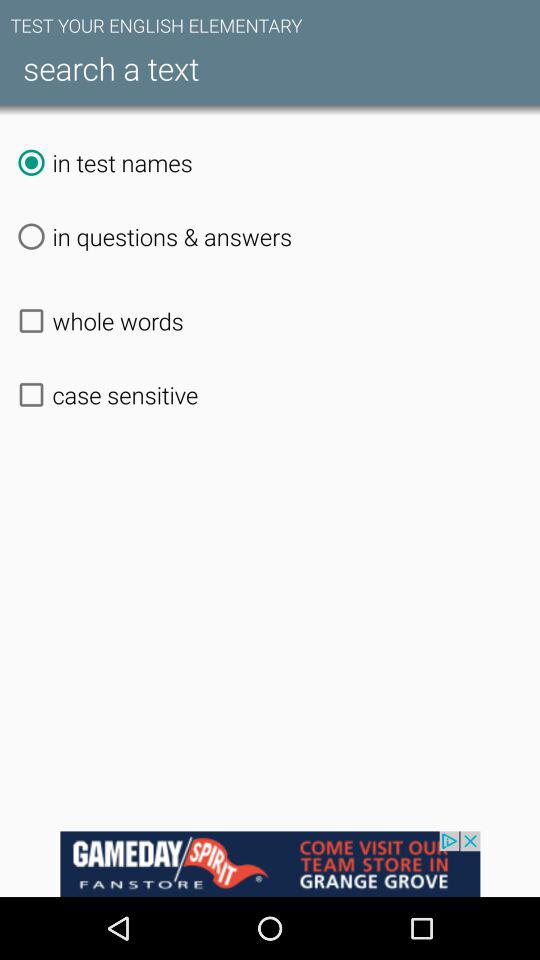Which option is selected? The selected option is "in test names". 